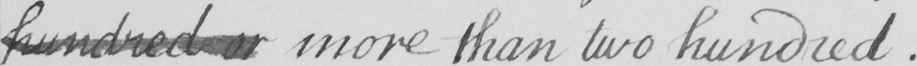Can you read and transcribe this handwriting? hundred or more than two hundred  . 